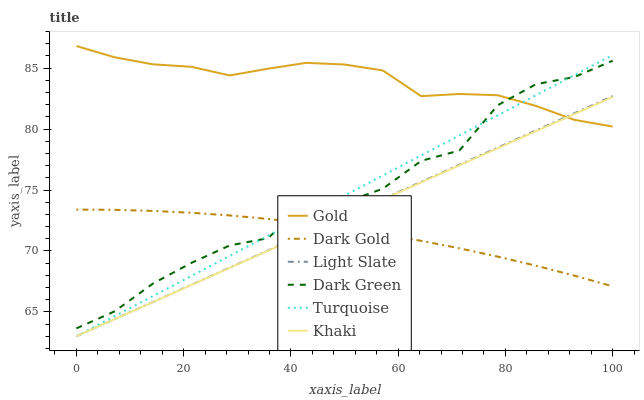Does Dark Gold have the minimum area under the curve?
Answer yes or no. Yes. Does Gold have the maximum area under the curve?
Answer yes or no. Yes. Does Khaki have the minimum area under the curve?
Answer yes or no. No. Does Khaki have the maximum area under the curve?
Answer yes or no. No. Is Turquoise the smoothest?
Answer yes or no. Yes. Is Dark Green the roughest?
Answer yes or no. Yes. Is Khaki the smoothest?
Answer yes or no. No. Is Khaki the roughest?
Answer yes or no. No. Does Gold have the lowest value?
Answer yes or no. No. Does Gold have the highest value?
Answer yes or no. Yes. Does Khaki have the highest value?
Answer yes or no. No. Is Dark Gold less than Gold?
Answer yes or no. Yes. Is Gold greater than Dark Gold?
Answer yes or no. Yes. Does Dark Gold intersect Gold?
Answer yes or no. No. 